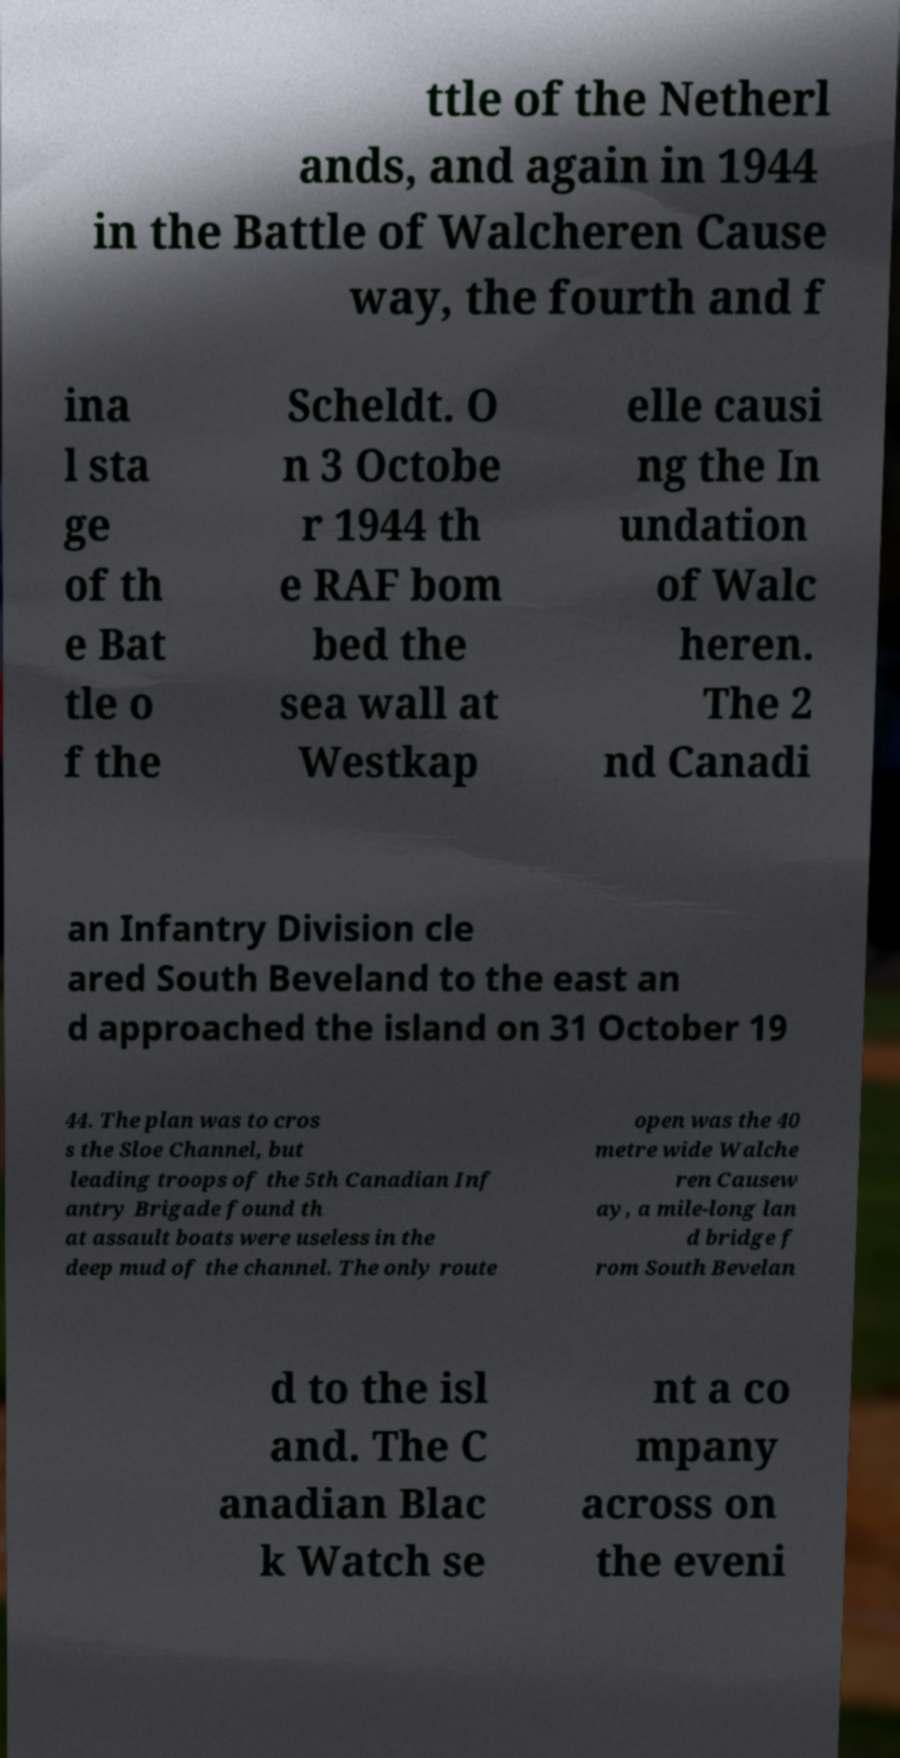Could you assist in decoding the text presented in this image and type it out clearly? ttle of the Netherl ands, and again in 1944 in the Battle of Walcheren Cause way, the fourth and f ina l sta ge of th e Bat tle o f the Scheldt. O n 3 Octobe r 1944 th e RAF bom bed the sea wall at Westkap elle causi ng the In undation of Walc heren. The 2 nd Canadi an Infantry Division cle ared South Beveland to the east an d approached the island on 31 October 19 44. The plan was to cros s the Sloe Channel, but leading troops of the 5th Canadian Inf antry Brigade found th at assault boats were useless in the deep mud of the channel. The only route open was the 40 metre wide Walche ren Causew ay, a mile-long lan d bridge f rom South Bevelan d to the isl and. The C anadian Blac k Watch se nt a co mpany across on the eveni 